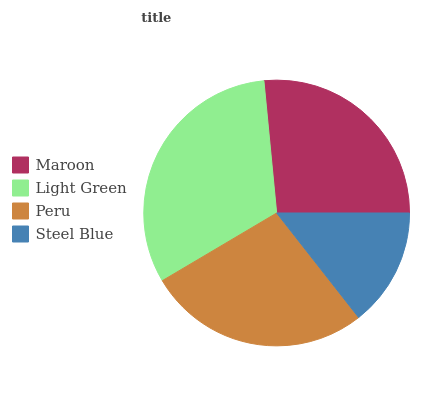Is Steel Blue the minimum?
Answer yes or no. Yes. Is Light Green the maximum?
Answer yes or no. Yes. Is Peru the minimum?
Answer yes or no. No. Is Peru the maximum?
Answer yes or no. No. Is Light Green greater than Peru?
Answer yes or no. Yes. Is Peru less than Light Green?
Answer yes or no. Yes. Is Peru greater than Light Green?
Answer yes or no. No. Is Light Green less than Peru?
Answer yes or no. No. Is Peru the high median?
Answer yes or no. Yes. Is Maroon the low median?
Answer yes or no. Yes. Is Steel Blue the high median?
Answer yes or no. No. Is Steel Blue the low median?
Answer yes or no. No. 